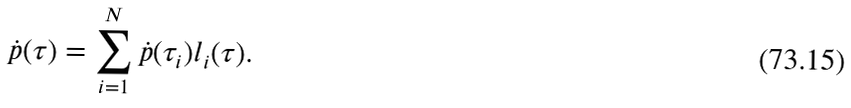<formula> <loc_0><loc_0><loc_500><loc_500>\dot { p } ( \tau ) = \sum _ { i = 1 } ^ { N } \dot { p } ( \tau _ { i } ) l _ { i } ( \tau ) .</formula> 